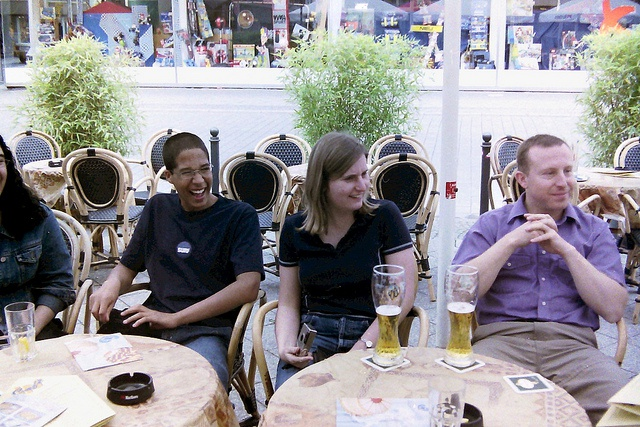Describe the objects in this image and their specific colors. I can see people in darkgray, purple, and gray tones, people in darkgray, black, gray, and maroon tones, people in darkgray, black, and gray tones, dining table in darkgray, lightgray, and pink tones, and dining table in darkgray, lightgray, black, and gray tones in this image. 